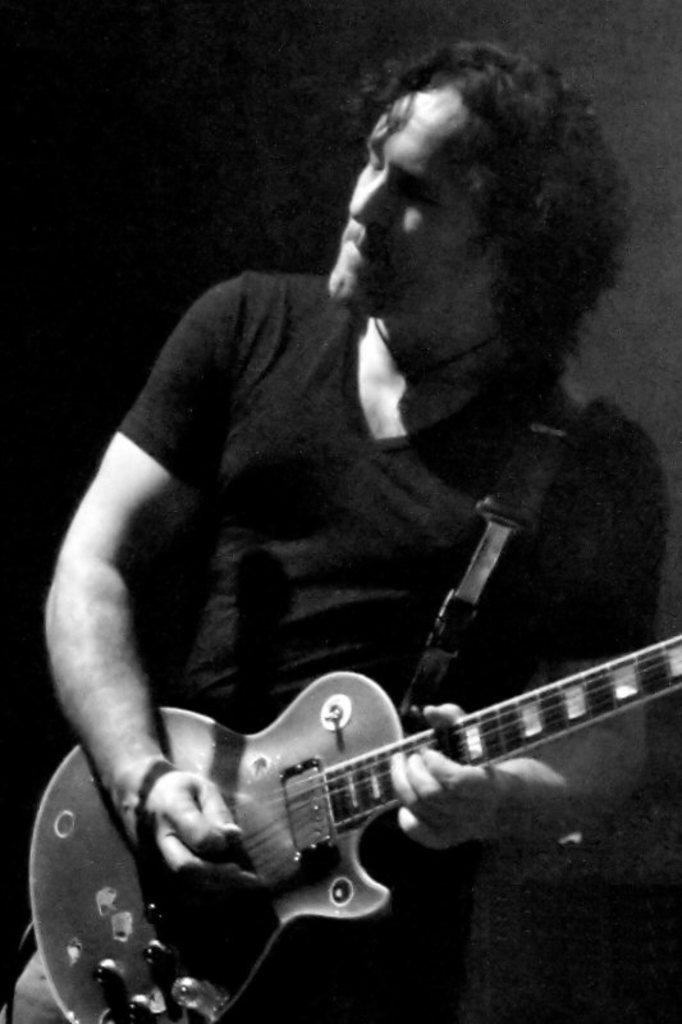What is the color scheme of the image? The image is black and white. Who is present in the image? There is a man in the image. What is the man doing in the image? The man is playing a guitar. What type of hospital equipment can be seen in the image? There is no hospital equipment present in the image; it features a man playing a guitar in a black and white setting. How many clouds are visible in the image? There are no clouds visible in the image, as it is black and white and does not depict an outdoor scene. 